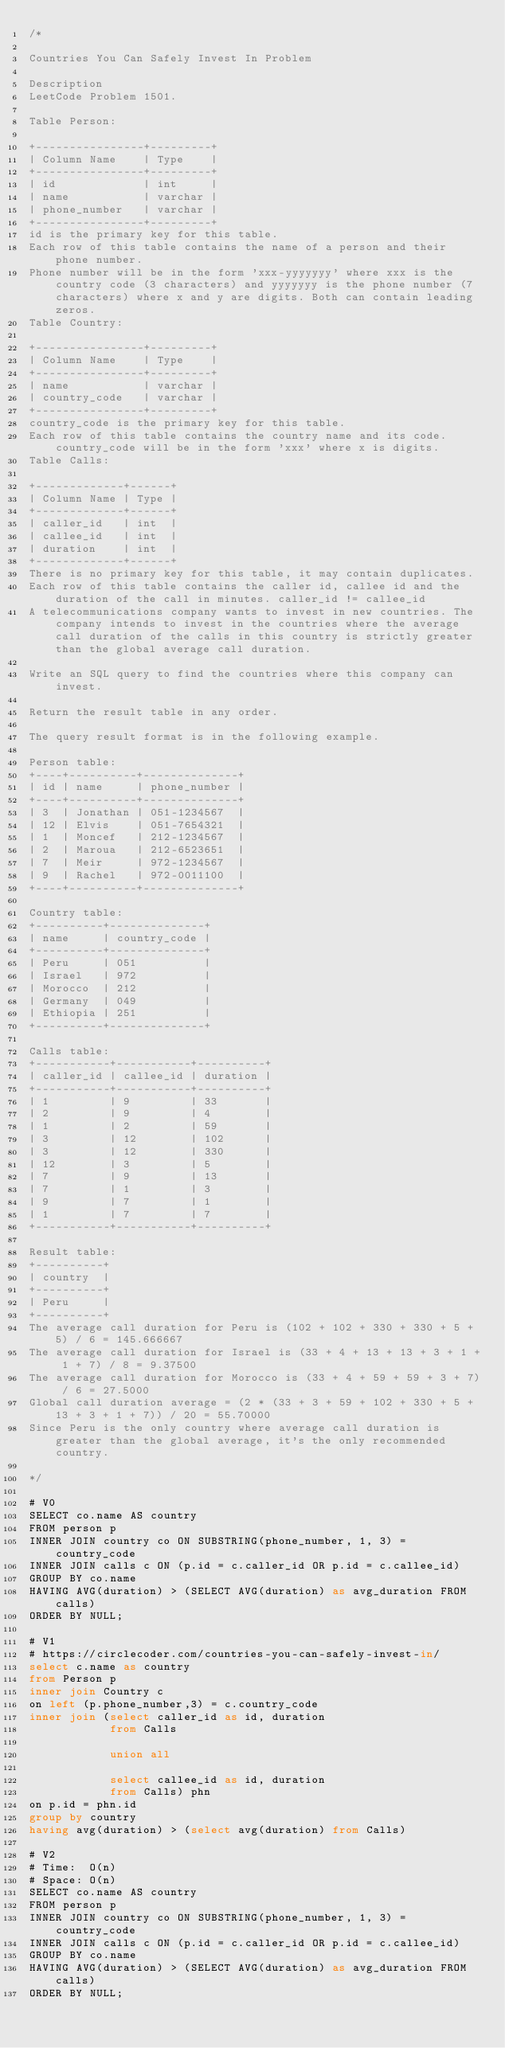Convert code to text. <code><loc_0><loc_0><loc_500><loc_500><_SQL_>/*

Countries You Can Safely Invest In Problem

Description
LeetCode Problem 1501.

Table Person:

+----------------+---------+
| Column Name    | Type    |
+----------------+---------+
| id             | int     |
| name           | varchar |
| phone_number   | varchar |
+----------------+---------+
id is the primary key for this table.
Each row of this table contains the name of a person and their phone number.
Phone number will be in the form 'xxx-yyyyyyy' where xxx is the country code (3 characters) and yyyyyyy is the phone number (7 characters) where x and y are digits. Both can contain leading zeros.
Table Country:

+----------------+---------+
| Column Name    | Type    |
+----------------+---------+
| name           | varchar |
| country_code   | varchar |
+----------------+---------+
country_code is the primary key for this table.
Each row of this table contains the country name and its code. country_code will be in the form 'xxx' where x is digits.
Table Calls:

+-------------+------+
| Column Name | Type |
+-------------+------+
| caller_id   | int  |
| callee_id   | int  |
| duration    | int  |
+-------------+------+
There is no primary key for this table, it may contain duplicates.
Each row of this table contains the caller id, callee id and the duration of the call in minutes. caller_id != callee_id
A telecommunications company wants to invest in new countries. The company intends to invest in the countries where the average call duration of the calls in this country is strictly greater than the global average call duration.

Write an SQL query to find the countries where this company can invest.

Return the result table in any order.

The query result format is in the following example.

Person table:
+----+----------+--------------+
| id | name     | phone_number |
+----+----------+--------------+
| 3  | Jonathan | 051-1234567  |
| 12 | Elvis    | 051-7654321  |
| 1  | Moncef   | 212-1234567  |
| 2  | Maroua   | 212-6523651  |
| 7  | Meir     | 972-1234567  |
| 9  | Rachel   | 972-0011100  |
+----+----------+--------------+

Country table:
+----------+--------------+
| name     | country_code |
+----------+--------------+
| Peru     | 051          |
| Israel   | 972          |
| Morocco  | 212          |
| Germany  | 049          |
| Ethiopia | 251          |
+----------+--------------+

Calls table:
+-----------+-----------+----------+
| caller_id | callee_id | duration |
+-----------+-----------+----------+
| 1         | 9         | 33       |
| 2         | 9         | 4        |
| 1         | 2         | 59       |
| 3         | 12        | 102      |
| 3         | 12        | 330      |
| 12        | 3         | 5        |
| 7         | 9         | 13       |
| 7         | 1         | 3        |
| 9         | 7         | 1        |
| 1         | 7         | 7        |
+-----------+-----------+----------+

Result table:
+----------+
| country  |
+----------+
| Peru     |
+----------+
The average call duration for Peru is (102 + 102 + 330 + 330 + 5 + 5) / 6 = 145.666667
The average call duration for Israel is (33 + 4 + 13 + 13 + 3 + 1 + 1 + 7) / 8 = 9.37500
The average call duration for Morocco is (33 + 4 + 59 + 59 + 3 + 7) / 6 = 27.5000 
Global call duration average = (2 * (33 + 3 + 59 + 102 + 330 + 5 + 13 + 3 + 1 + 7)) / 20 = 55.70000
Since Peru is the only country where average call duration is greater than the global average, it's the only recommended country.

*/

# V0
SELECT co.name AS country
FROM person p
INNER JOIN country co ON SUBSTRING(phone_number, 1, 3) = country_code
INNER JOIN calls c ON (p.id = c.caller_id OR p.id = c.callee_id)
GROUP BY co.name
HAVING AVG(duration) > (SELECT AVG(duration) as avg_duration FROM calls)
ORDER BY NULL;

# V1
# https://circlecoder.com/countries-you-can-safely-invest-in/
select c.name as country 
from Person p 
inner join Country c 
on left (p.phone_number,3) = c.country_code 
inner join (select caller_id as id, duration 
            from Calls 
            
            union all 
            
            select callee_id as id, duration 
            from Calls) phn 
on p.id = phn.id 
group by country 
having avg(duration) > (select avg(duration) from Calls)

# V2
# Time:  O(n)
# Space: O(n)
SELECT co.name AS country
FROM person p
INNER JOIN country co ON SUBSTRING(phone_number, 1, 3) = country_code
INNER JOIN calls c ON (p.id = c.caller_id OR p.id = c.callee_id)
GROUP BY co.name
HAVING AVG(duration) > (SELECT AVG(duration) as avg_duration FROM calls)
ORDER BY NULL;</code> 